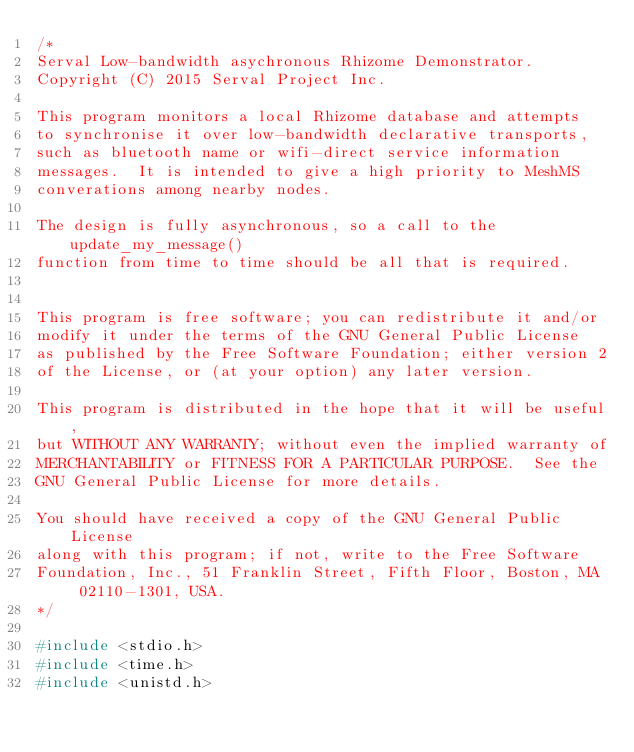Convert code to text. <code><loc_0><loc_0><loc_500><loc_500><_C_>/*
Serval Low-bandwidth asychronous Rhizome Demonstrator.
Copyright (C) 2015 Serval Project Inc.

This program monitors a local Rhizome database and attempts
to synchronise it over low-bandwidth declarative transports, 
such as bluetooth name or wifi-direct service information
messages.  It is intended to give a high priority to MeshMS
converations among nearby nodes.

The design is fully asynchronous, so a call to the update_my_message()
function from time to time should be all that is required.


This program is free software; you can redistribute it and/or
modify it under the terms of the GNU General Public License
as published by the Free Software Foundation; either version 2
of the License, or (at your option) any later version.

This program is distributed in the hope that it will be useful,
but WITHOUT ANY WARRANTY; without even the implied warranty of
MERCHANTABILITY or FITNESS FOR A PARTICULAR PURPOSE.  See the
GNU General Public License for more details.

You should have received a copy of the GNU General Public License
along with this program; if not, write to the Free Software
Foundation, Inc., 51 Franklin Street, Fifth Floor, Boston, MA  02110-1301, USA.
*/

#include <stdio.h>
#include <time.h>
#include <unistd.h></code> 